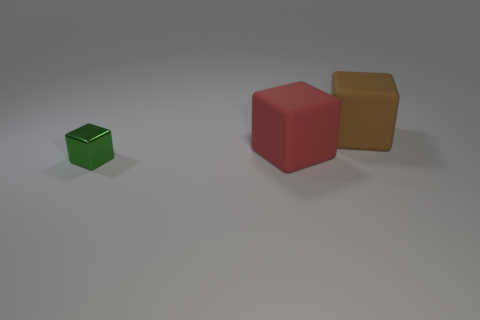Add 2 big blocks. How many objects exist? 5 Add 2 small blue metal cylinders. How many small blue metal cylinders exist? 2 Subtract 0 purple blocks. How many objects are left? 3 Subtract all red rubber blocks. Subtract all large red objects. How many objects are left? 1 Add 3 red blocks. How many red blocks are left? 4 